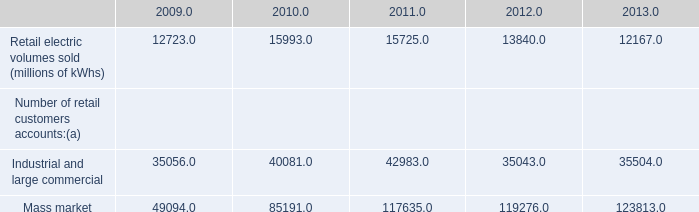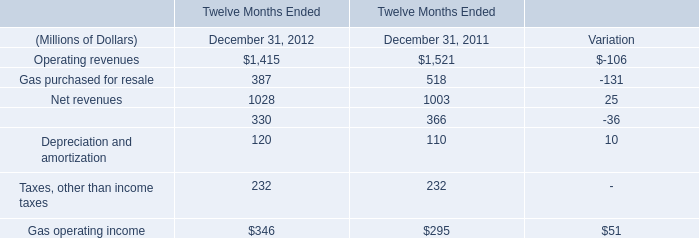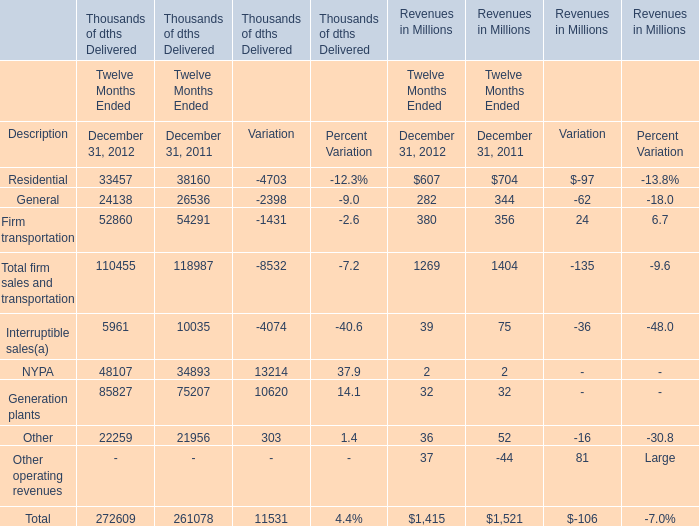What is the proportion of the Net revenues in 2011 Ended December 31 to the sum of the Operating revenues and the Net revenues in 2011 Ended December 31? 
Computations: (1003 / (1521 + 1003))
Answer: 0.39739. 